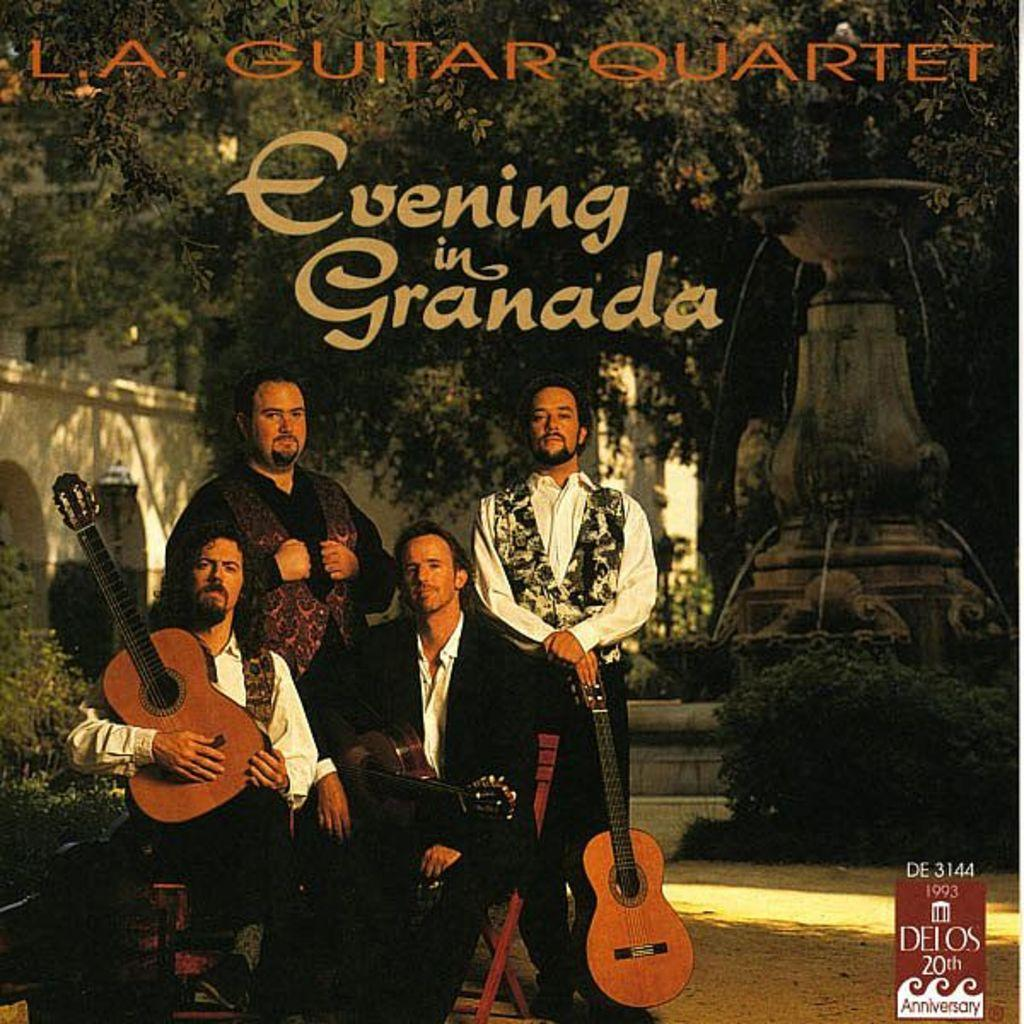How many musicians are present in the image? There are 4 musicians in the image. What are the musicians doing in the image? The musicians are sitting on chairs and holding guitars. What can be seen in the background of the image? There are trees, a statue, plants, and a building visible in the distance. What type of berry is being used as a collar for the toad in the image? There is no toad or berry present in the image. 